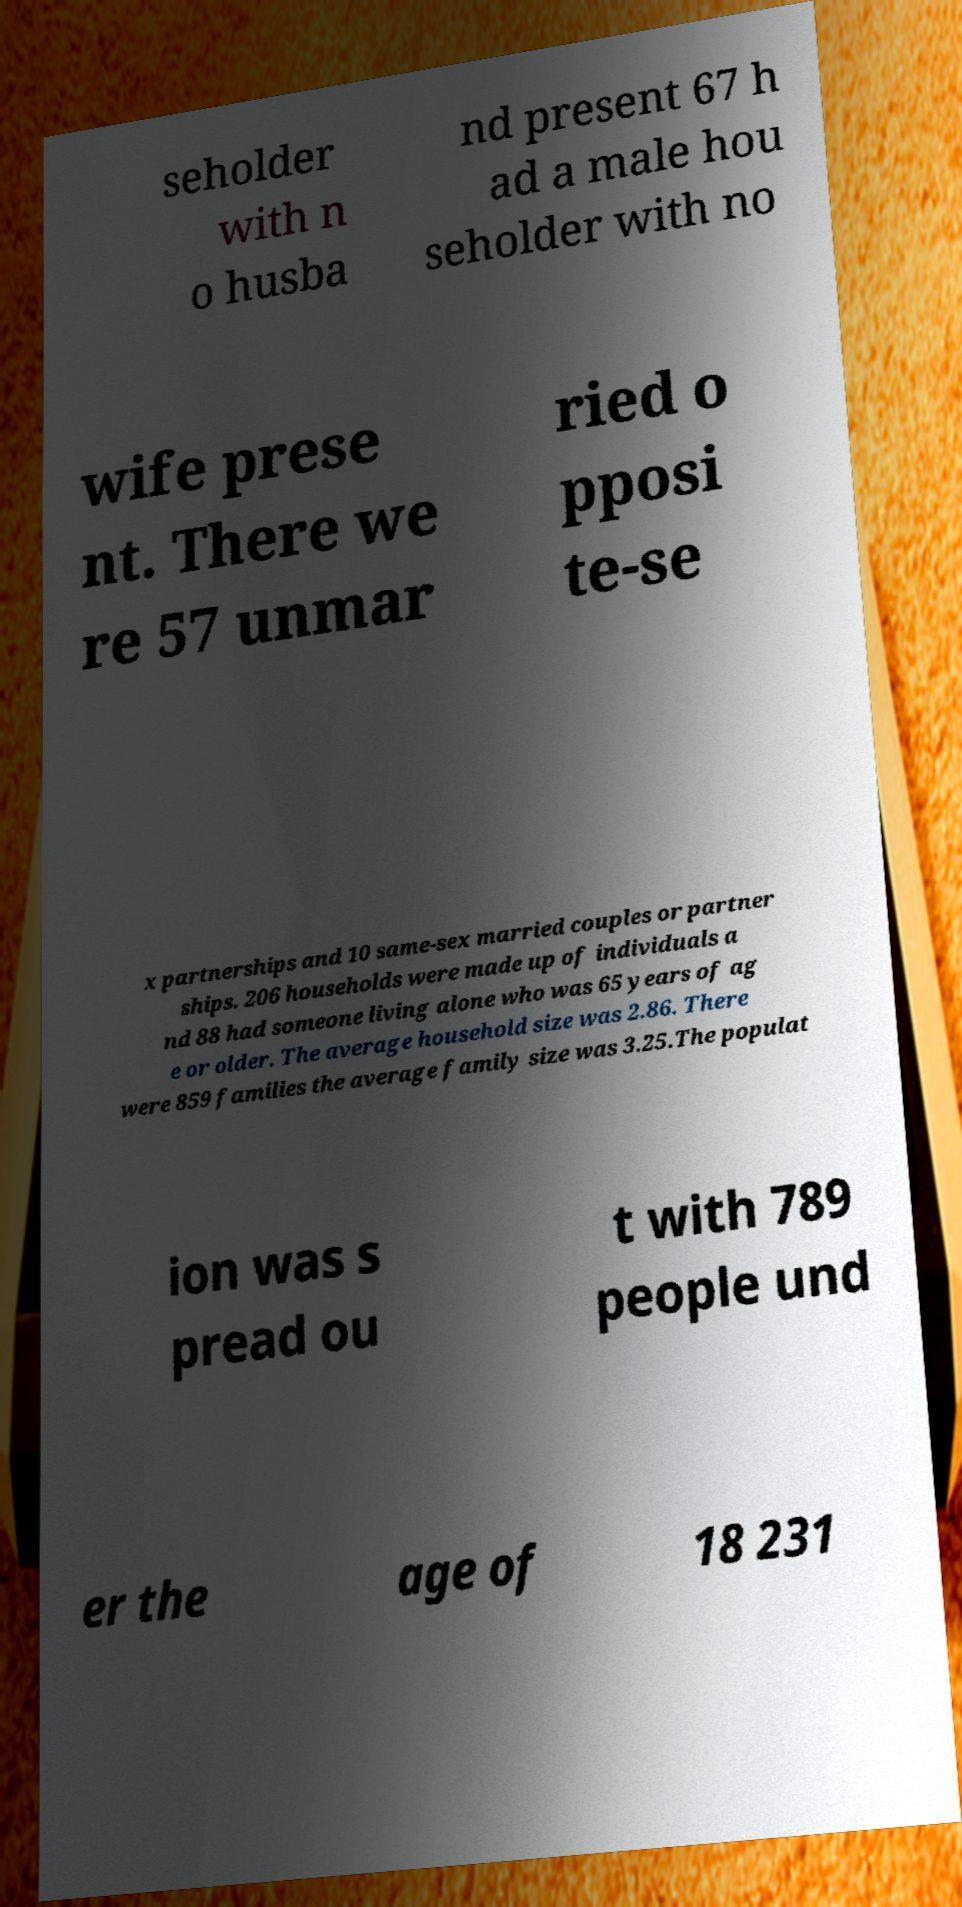For documentation purposes, I need the text within this image transcribed. Could you provide that? seholder with n o husba nd present 67 h ad a male hou seholder with no wife prese nt. There we re 57 unmar ried o pposi te-se x partnerships and 10 same-sex married couples or partner ships. 206 households were made up of individuals a nd 88 had someone living alone who was 65 years of ag e or older. The average household size was 2.86. There were 859 families the average family size was 3.25.The populat ion was s pread ou t with 789 people und er the age of 18 231 